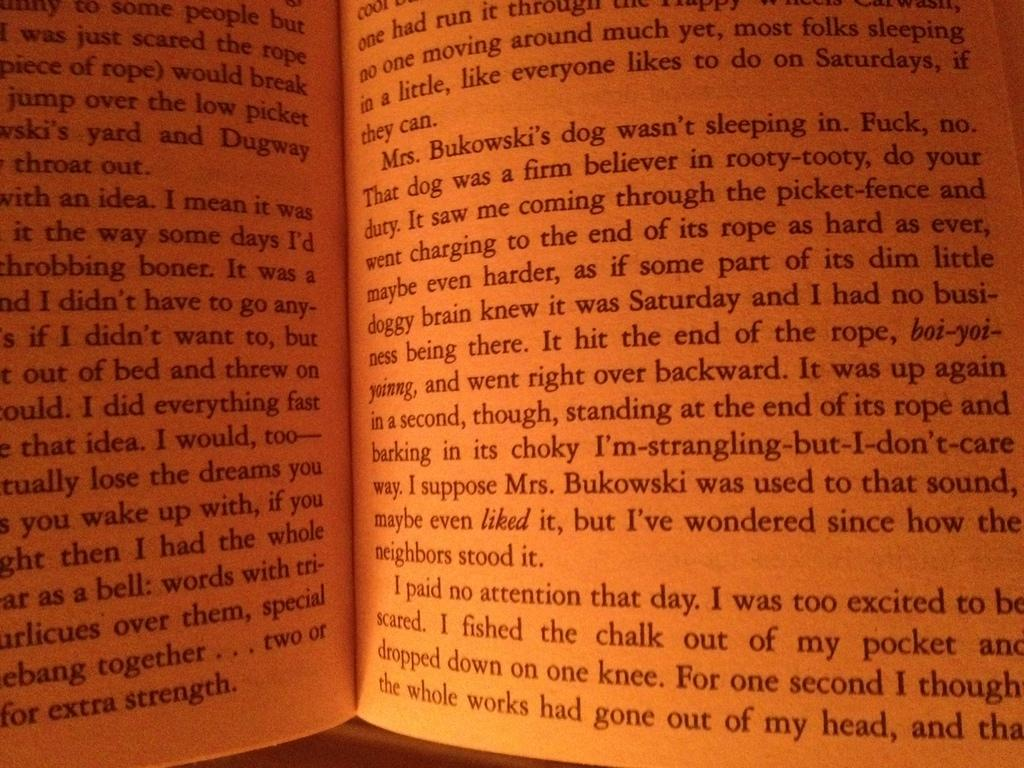<image>
Create a compact narrative representing the image presented. Pages with writing in black about Mrs. Bukowski. 